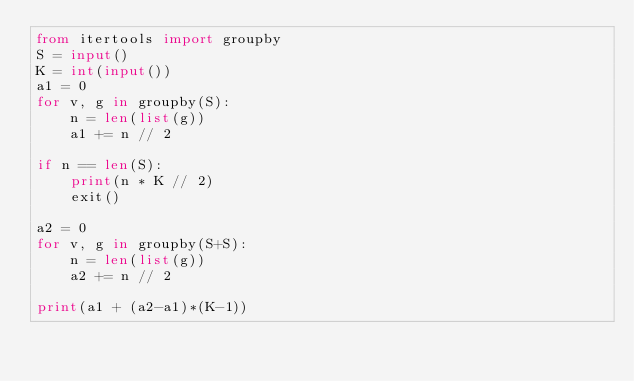<code> <loc_0><loc_0><loc_500><loc_500><_Python_>from itertools import groupby
S = input()
K = int(input())
a1 = 0
for v, g in groupby(S):
    n = len(list(g))
    a1 += n // 2

if n == len(S):
    print(n * K // 2)
    exit()

a2 = 0
for v, g in groupby(S+S):
    n = len(list(g))
    a2 += n // 2

print(a1 + (a2-a1)*(K-1))
</code> 